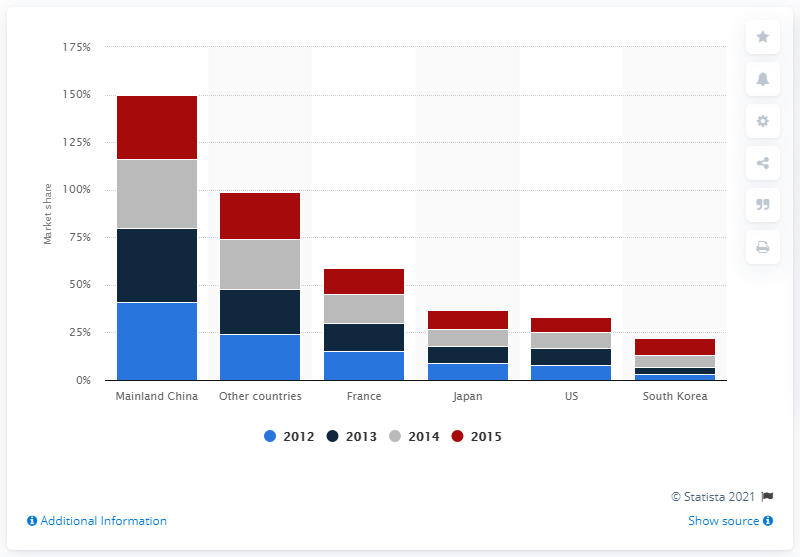Highlight a few significant elements in this photo. In 2015, imported French personal care and cosmetic products accounted for approximately 14% of the total personal care and cosmetic market in Hong Kong. 